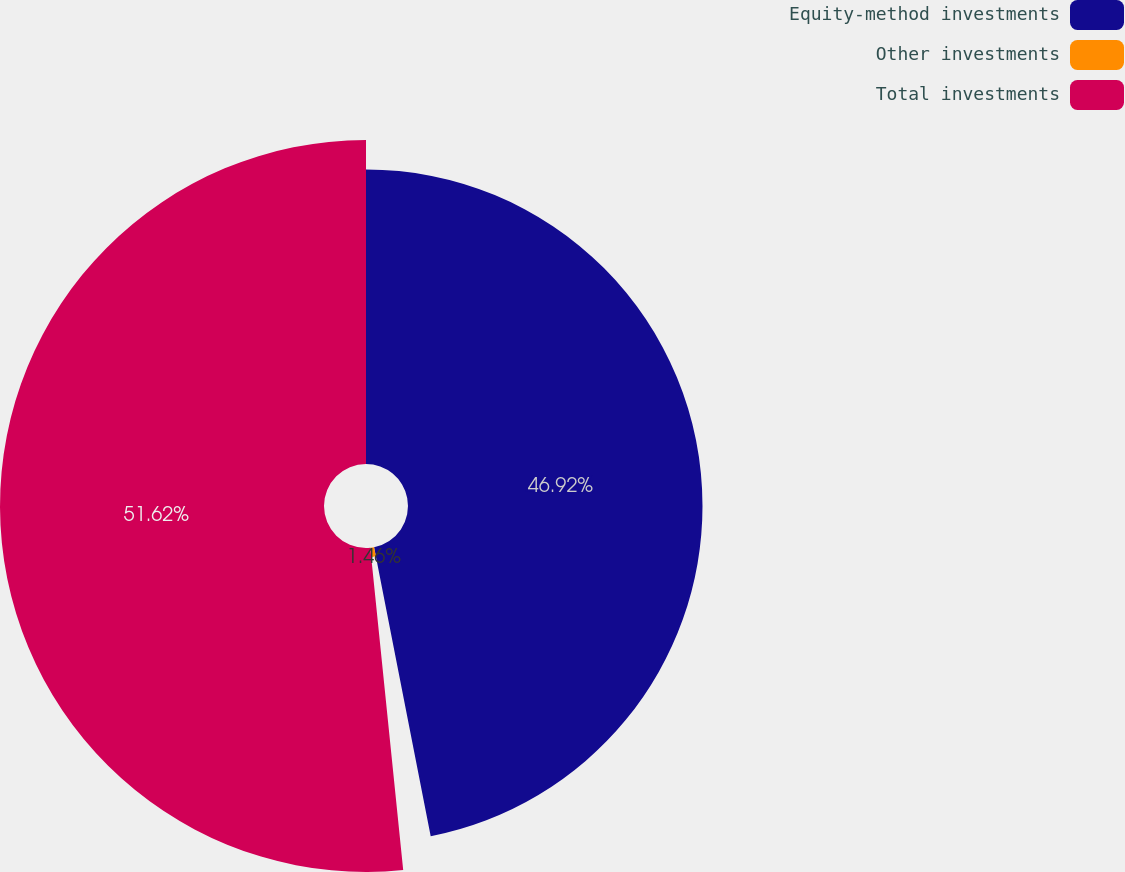<chart> <loc_0><loc_0><loc_500><loc_500><pie_chart><fcel>Equity-method investments<fcel>Other investments<fcel>Total investments<nl><fcel>46.92%<fcel>1.46%<fcel>51.62%<nl></chart> 